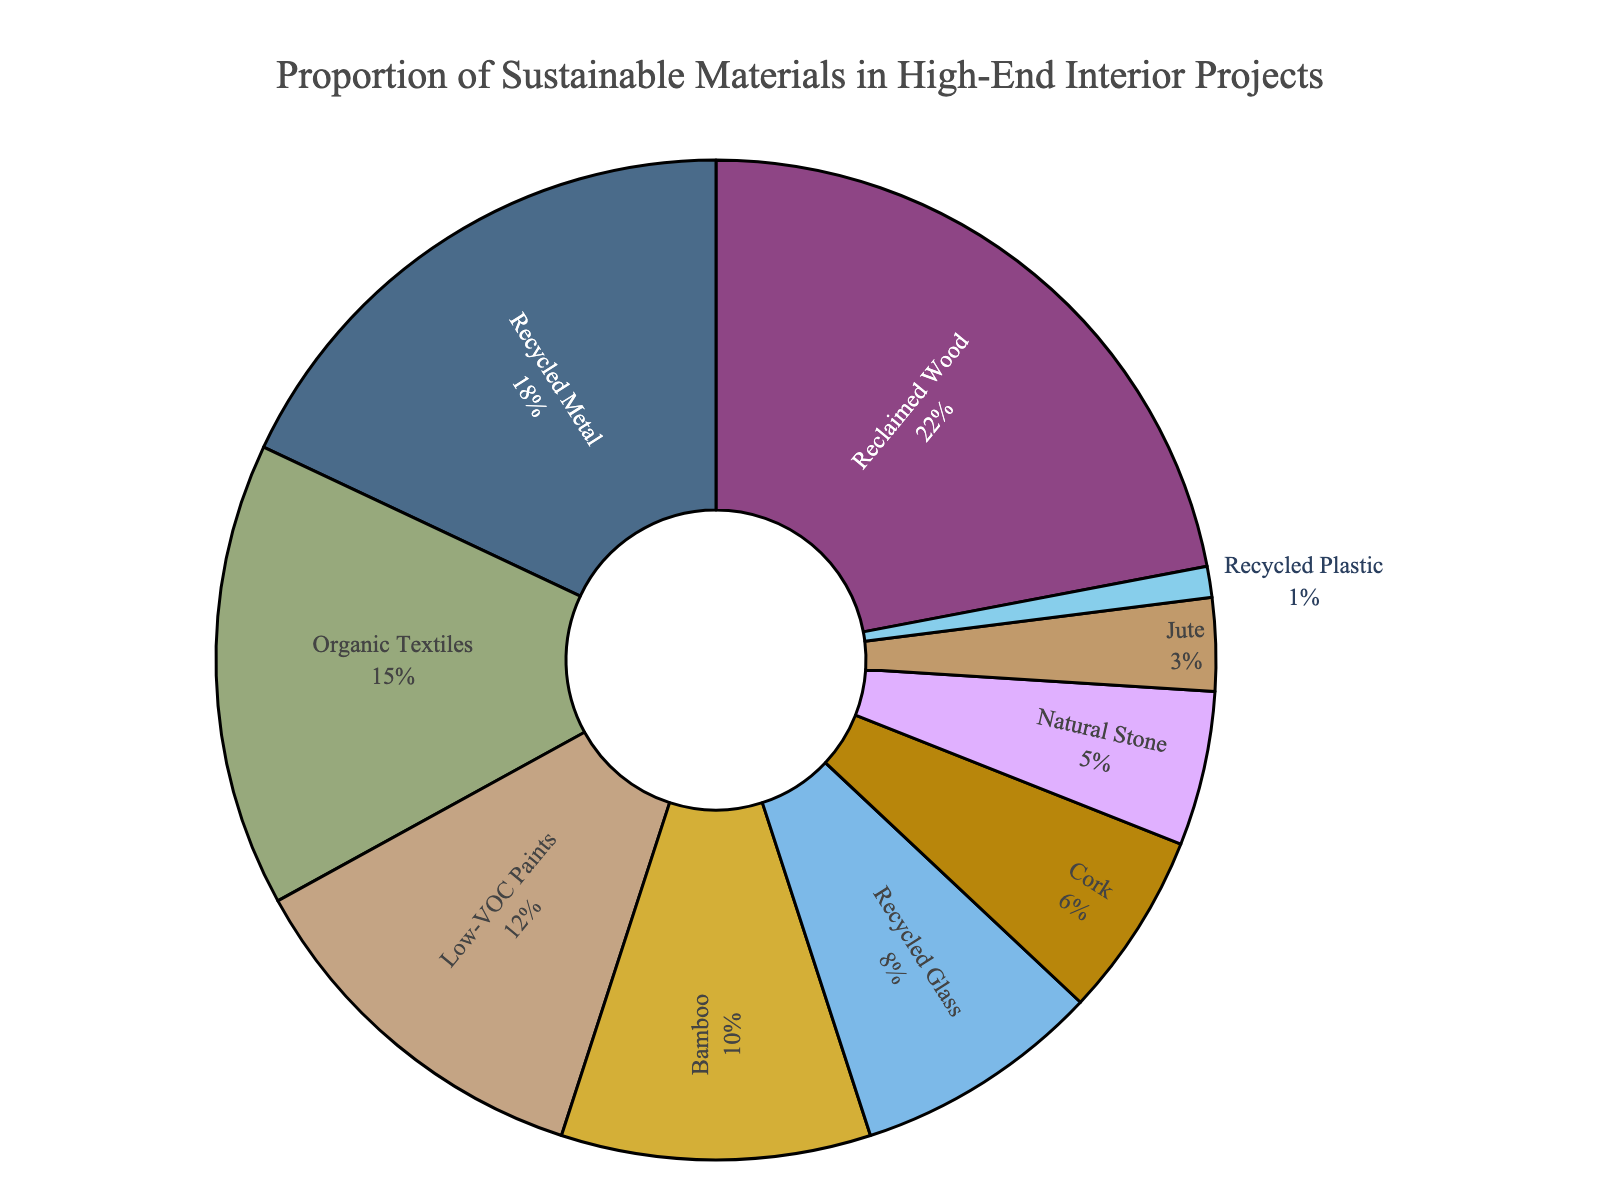Which material has the highest proportion in the chart? To find the material with the highest proportion, look for the section with the largest percentage value. In this case, "Reclaimed Wood" has the highest proportion at 22%.
Answer: Reclaimed Wood What is the total percentage of Recycled Metal and Organic Textiles combined? Add the percentages of "Recycled Metal" (18%) and "Organic Textiles" (15%). 18% + 15% = 33%
Answer: 33% Which material has the smallest proportion? Locate the material with the smallest wedge in the pie chart, along with the percentage label. "Recycled Plastic" has the smallest proportion at 1%.
Answer: Recycled Plastic How much more proportion does Bamboo have compared to Cork? Subtract the percentage of Cork (6%) from the percentage of Bamboo (10%). 10% - 6% = 4%
Answer: 4% Arrange the materials with more than 10% proportion in descending order. Identify materials with more than 10% proportion: Reclaimed Wood (22%), Recycled Metal (18%), Organic Textiles (15%), Low-VOC Paints (12%). Arrange them: 22%, 18%, 15%, 12%.
Answer: Reclaimed Wood, Recycled Metal, Organic Textiles, Low-VOC Paints What is the proportion of materials with percentages less than 5%? Add the percentages of materials with values less than 5%: Natural Stone (5%), Jute (3%), Recycled Plastic (1%). 5% + 3% + 1% = 9%
Answer: 9% Which has a higher proportion, Bamboo or Organic Textiles, and by how much? Compare the percentages: Bamboo (10%) and Organic Textiles (15%). Subtract the smaller percentage from the larger: 15% - 10% = 5%. Organic Textiles has 5% more.
Answer: Organic Textiles, 5% If you combine the proportions of Recycled Glass and Jute, do they exceed that of Low-VOC Paints? Add the percentages of Recycled Glass (8%) and Jute (3%) and compare the sum with the percentage of Low-VOC Paints (12%). 8% + 3% = 11%, which is less than 12%.
Answer: No What is the total percentage of Reclaimed Wood, Recycled Metal, and Organic Textiles? Add the percentages of Reclaimed Wood (22%), Recycled Metal (18%), and Organic Textiles (15%). 22% + 18% + 15% = 55%.
Answer: 55% Which materials have proportions that are closer together in value, Bamboo and Recycled Glass, or Cork and Natural Stone? Compare the differences in proportions: Bamboo (10%) and Recycled Glass (8%) differ by 2%. Cork (6%) and Natural Stone (5%) differ by 1%. Cork and Natural Stone are closer.
Answer: Cork and Natural Stone 